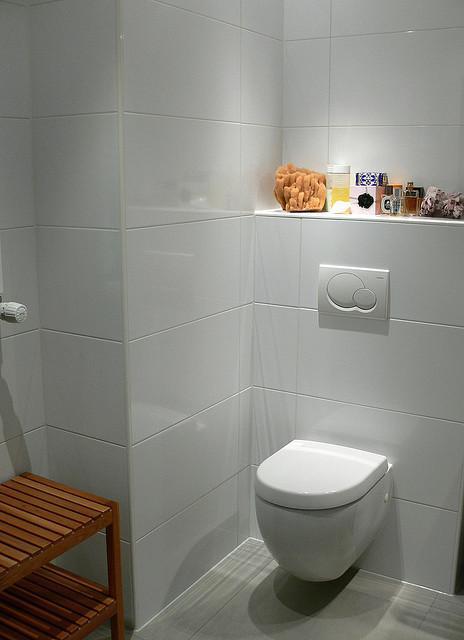How many birds flying?
Give a very brief answer. 0. 